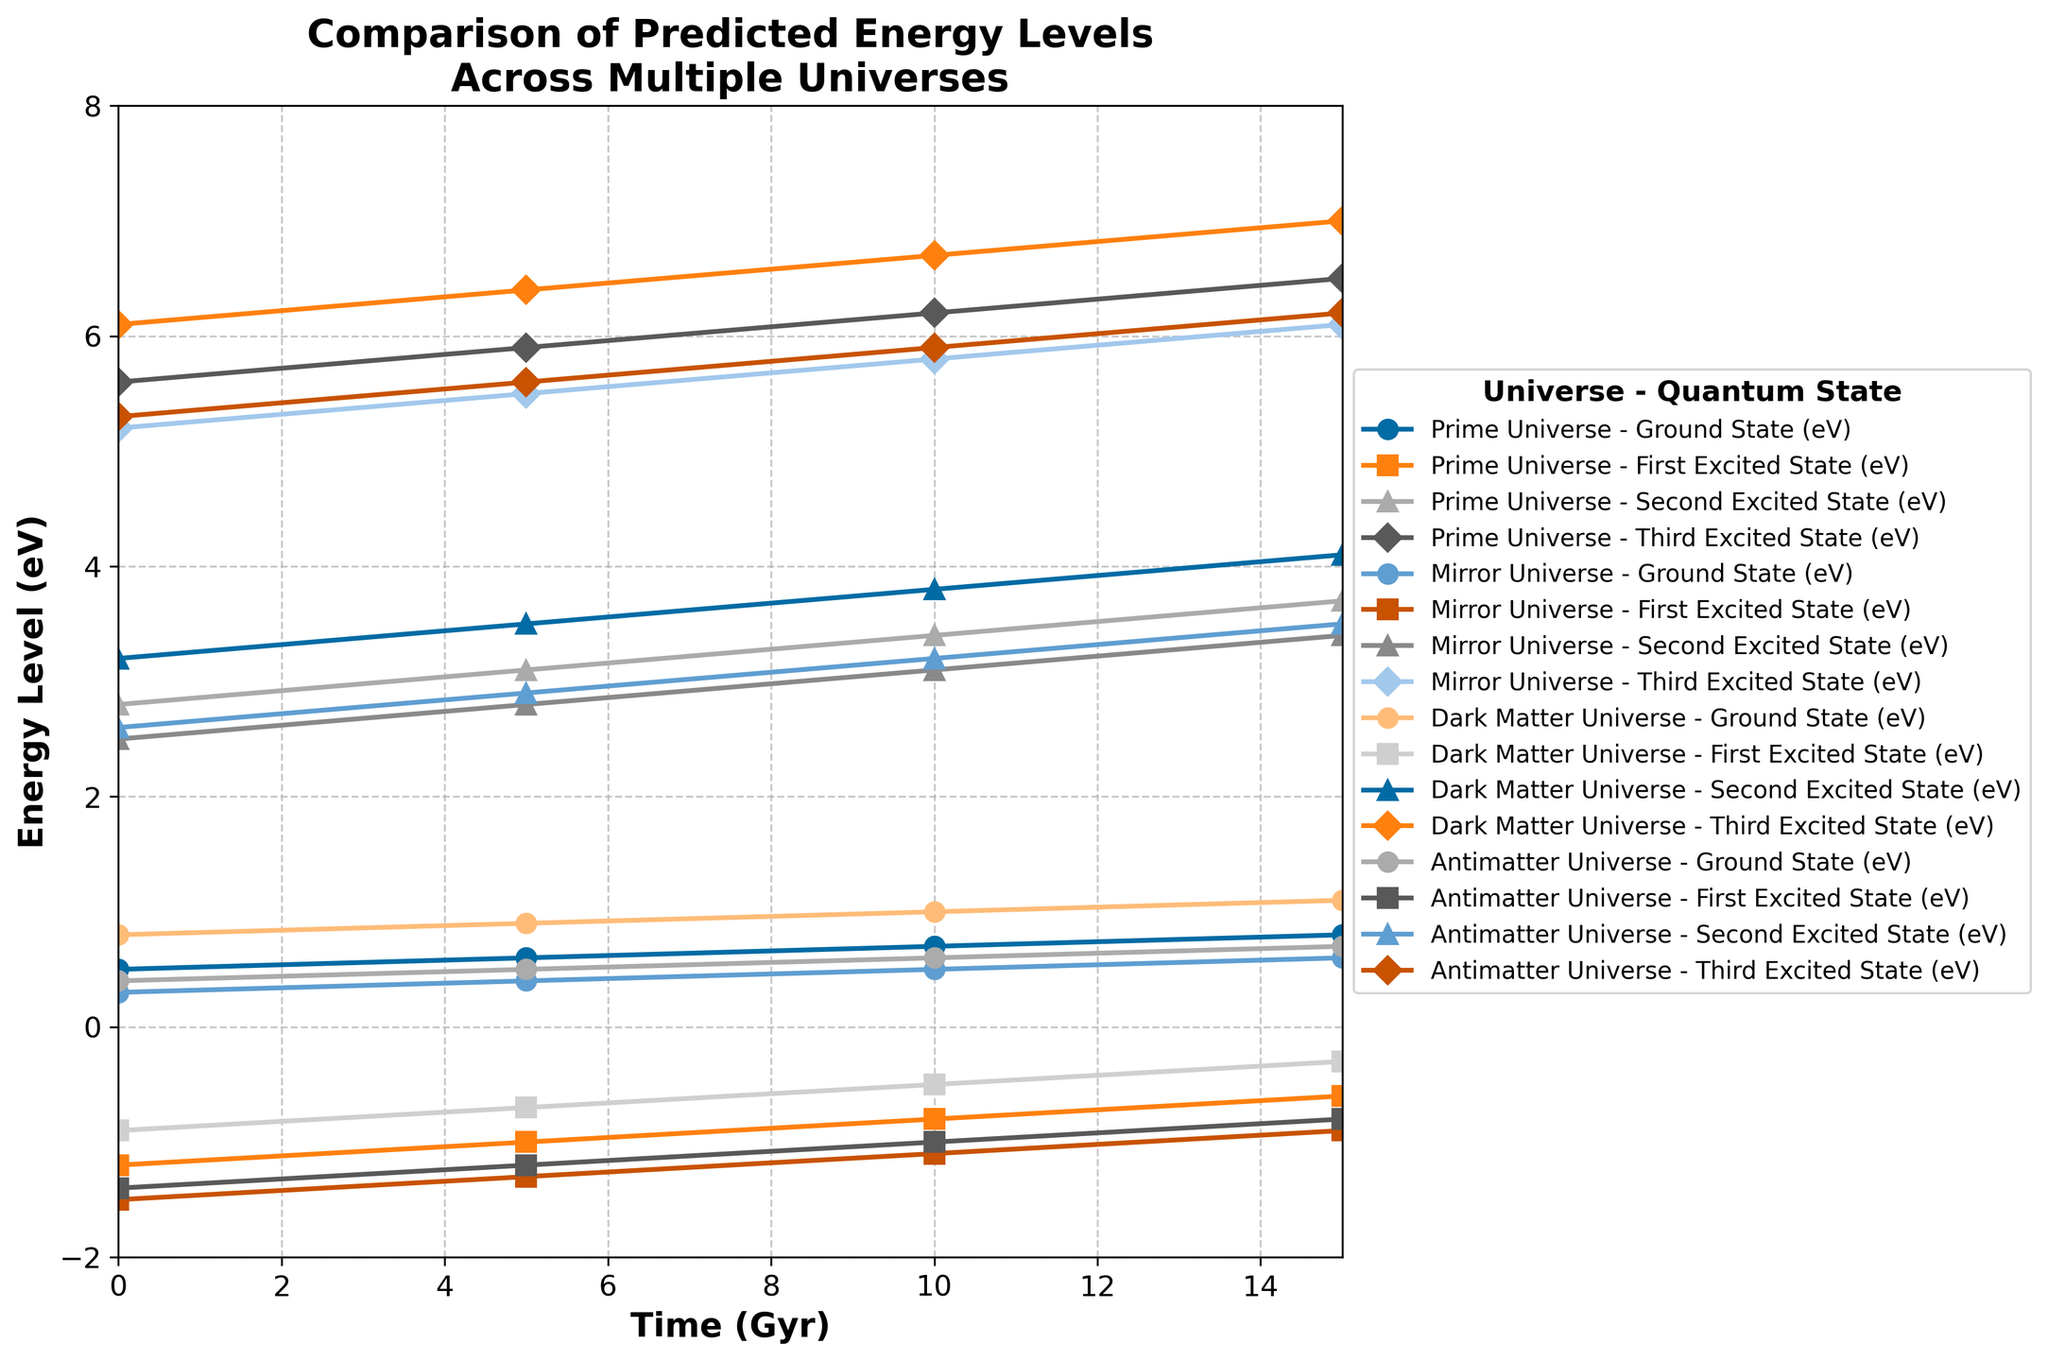Which universe has the highest Ground State energy at Time 15 Gyr? To find this, look at the Ground State (eV) values at Time 15 Gyr for each universe: Prime Universe (0.8 eV), Mirror Universe (0.6 eV), Dark Matter Universe (1.1 eV), Antimatter Universe (0.7 eV). The highest value is 1.1 eV from the Dark Matter Universe.
Answer: Dark Matter Universe Which excited state level shows the most significant change in energy over time in the Mirror Universe? Evaluate the changes for each excited state in the Mirror Universe. Ground State: 0.3 to 0.6 eV, a change of 0.3 eV. First Excited State: -1.5 to -0.9 eV, a change of 0.6 eV. Second Excited State: 2.5 to 3.4 eV, a change of 0.9 eV. Third Excited State: 5.2 to 6.1 eV, a change of 0.9 eV. The Second and Third Excited States both show the most significant change, 0.9 eV.
Answer: Second and Third Excited States Is the Ground State energy in the Prime Universe ever higher than in the Dark Matter Universe at any point in time? Compare the Ground State energies of the Prime Universe and the Dark Matter Universe at 0, 5, 10, and 15 Gyr. At every point (0.5 vs. 0.8, 0.6 vs. 0.9, 0.7 vs. 1.0, 0.8 vs. 1.1), the Ground State energy in the Dark Matter Universe is higher. Therefore, it is never higher in the Prime Universe.
Answer: No Which universe has the smallest energy difference between the Ground State and the First Excited State at Time 10 Gyr? Calculate the differences: Prime Universe (0.7 - -0.8 = 1.5 eV), Mirror Universe (0.5 - -1.1 = 1.6 eV), Dark Matter Universe (1.0 - -0.5 = 1.5 eV), Antimatter Universe (0.6 - -1.0 = 1.6 eV). Both the Prime Universe and the Dark Matter Universe have the smallest difference of 1.5 eV.
Answer: Prime Universe and Dark Matter Universe At what time does the Third Excited State in the Antimatter Universe surpass 6.0 eV? Review the Third Excited State energy levels in the Antimatter Universe over time: 5.3 eV (0 Gyr), 5.6 eV (5 Gyr), 5.9 eV (10 Gyr), 6.2 eV (15 Gyr). The level surpasses 6.0 eV at 15 Gyr.
Answer: 15 Gyr How does the Ground State energy in the Mirror Universe change over 15 Gyr? Track the values over time: 0 Gyr (0.3 eV), 5 Gyr (0.4 eV), 10 Gyr (0.5 eV), 15 Gyr (0.6 eV). There's a consistent increase by 0.1 eV every 5 Gyr.
Answer: Consistently increases by 0.1 eV every 5 Gyr What is the average energy of the First Excited State in the Prime Universe over the 15 Gyr period? Sum the values at 0, 5, 10, and 15 Gyr: -1.2, -1.0, -0.8, -0.6. The total is -3.6. Dividing by the number of points (4), the average is -3.6 / 4 = -0.9 eV.
Answer: -0.9 eV In which universe is the Second Excited State energy at 10 Gyr the highest? Compare Second Excited State energies at 10 Gyr: Prime Universe (3.4 eV), Mirror Universe (3.1 eV), Dark Matter Universe (3.8 eV), Antimatter Universe (3.2 eV). The highest value is 3.8 eV in the Dark Matter Universe.
Answer: Dark Matter Universe 